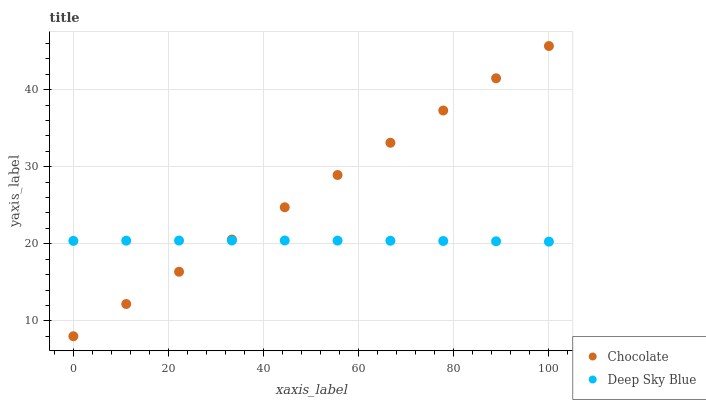Does Deep Sky Blue have the minimum area under the curve?
Answer yes or no. Yes. Does Chocolate have the maximum area under the curve?
Answer yes or no. Yes. Does Chocolate have the minimum area under the curve?
Answer yes or no. No. Is Chocolate the smoothest?
Answer yes or no. Yes. Is Deep Sky Blue the roughest?
Answer yes or no. Yes. Is Chocolate the roughest?
Answer yes or no. No. Does Chocolate have the lowest value?
Answer yes or no. Yes. Does Chocolate have the highest value?
Answer yes or no. Yes. Does Chocolate intersect Deep Sky Blue?
Answer yes or no. Yes. Is Chocolate less than Deep Sky Blue?
Answer yes or no. No. Is Chocolate greater than Deep Sky Blue?
Answer yes or no. No. 